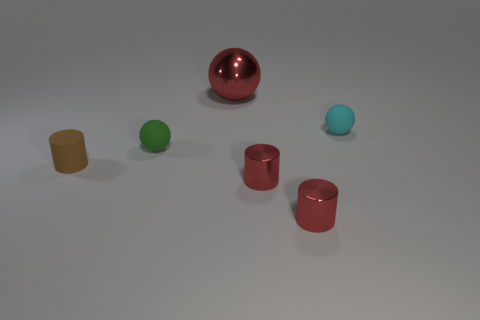How many shiny balls are in front of the thing behind the cyan ball?
Give a very brief answer. 0. How many objects are small cylinders to the right of the small brown rubber object or tiny green matte things?
Provide a succinct answer. 3. There is a shiny thing behind the brown rubber object; what is its size?
Your answer should be compact. Large. What material is the cyan sphere?
Make the answer very short. Rubber. The red object behind the tiny green rubber object left of the tiny cyan rubber thing is what shape?
Keep it short and to the point. Sphere. What number of other things are there of the same shape as the big object?
Make the answer very short. 2. There is a small cyan rubber object; are there any tiny rubber objects on the left side of it?
Give a very brief answer. Yes. The large sphere has what color?
Ensure brevity in your answer.  Red. Is the color of the small rubber cylinder the same as the metallic object that is behind the brown cylinder?
Your answer should be very brief. No. Are there any brown metallic cylinders of the same size as the brown matte cylinder?
Ensure brevity in your answer.  No. 